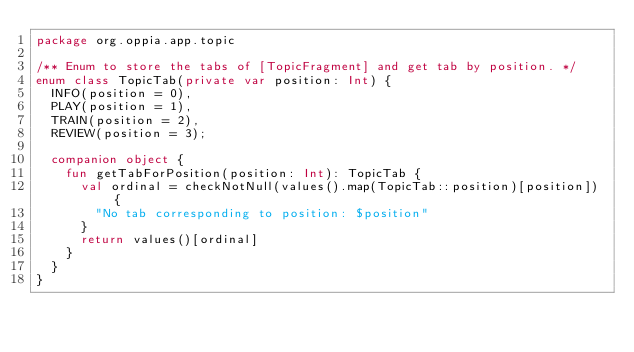<code> <loc_0><loc_0><loc_500><loc_500><_Kotlin_>package org.oppia.app.topic

/** Enum to store the tabs of [TopicFragment] and get tab by position. */
enum class TopicTab(private var position: Int) {
  INFO(position = 0),
  PLAY(position = 1),
  TRAIN(position = 2),
  REVIEW(position = 3);

  companion object {
    fun getTabForPosition(position: Int): TopicTab {
      val ordinal = checkNotNull(values().map(TopicTab::position)[position]) {
        "No tab corresponding to position: $position"
      }
      return values()[ordinal]
    }
  }
}
</code> 